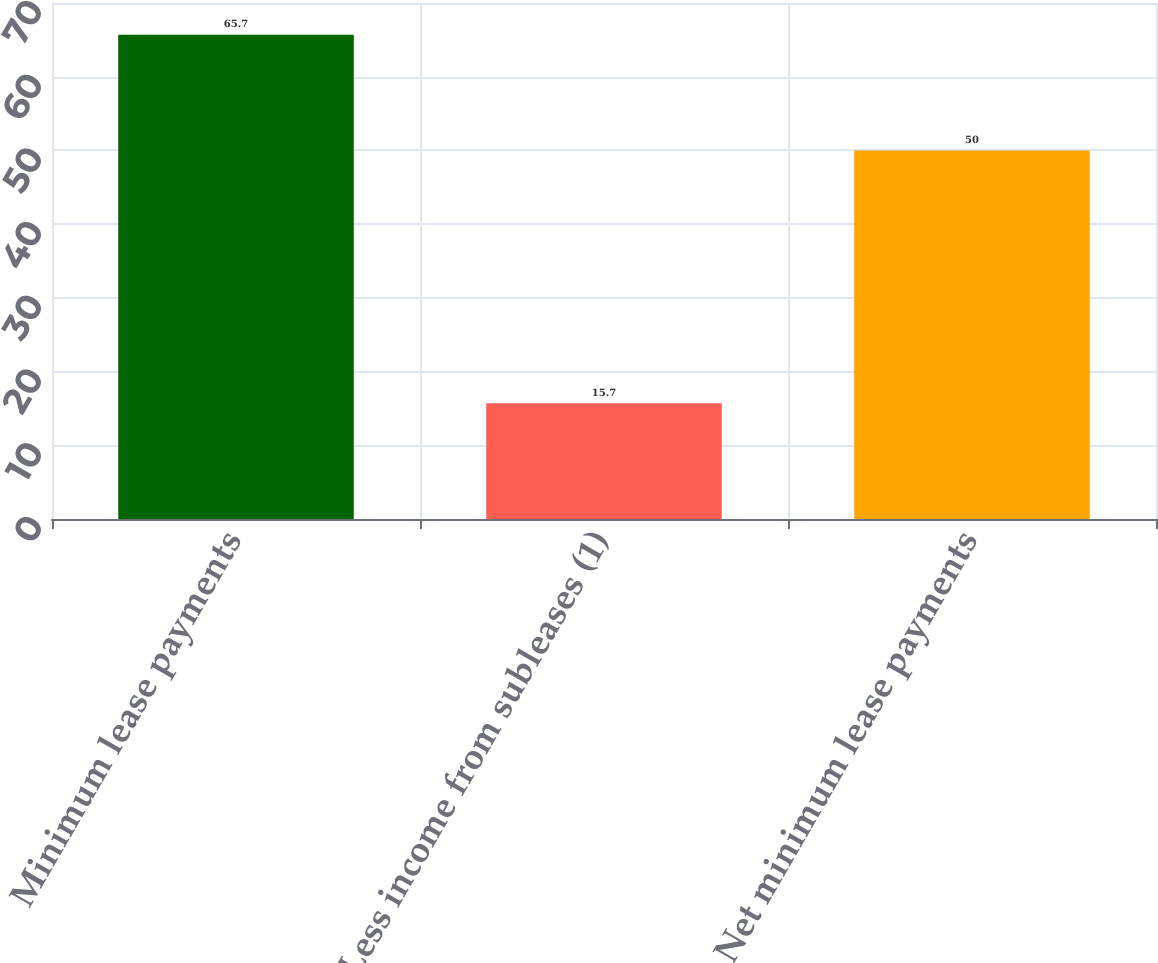Convert chart to OTSL. <chart><loc_0><loc_0><loc_500><loc_500><bar_chart><fcel>Minimum lease payments<fcel>Less income from subleases (1)<fcel>Net minimum lease payments<nl><fcel>65.7<fcel>15.7<fcel>50<nl></chart> 